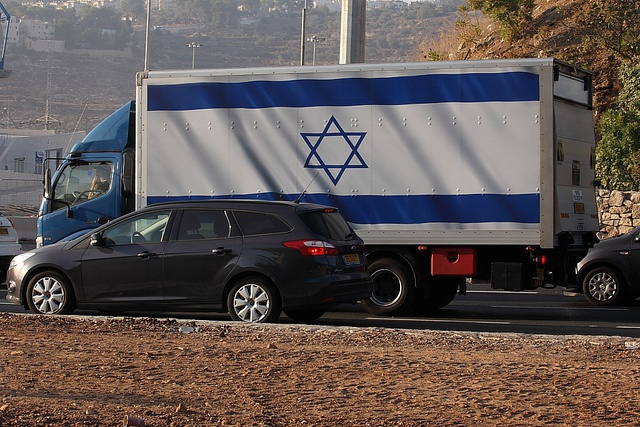Describe the objects in this image and their specific colors. I can see truck in gray, darkgray, navy, and black tones, car in gray, black, and darkgray tones, car in gray, black, and darkgray tones, car in gray and black tones, and people in gray and black tones in this image. 